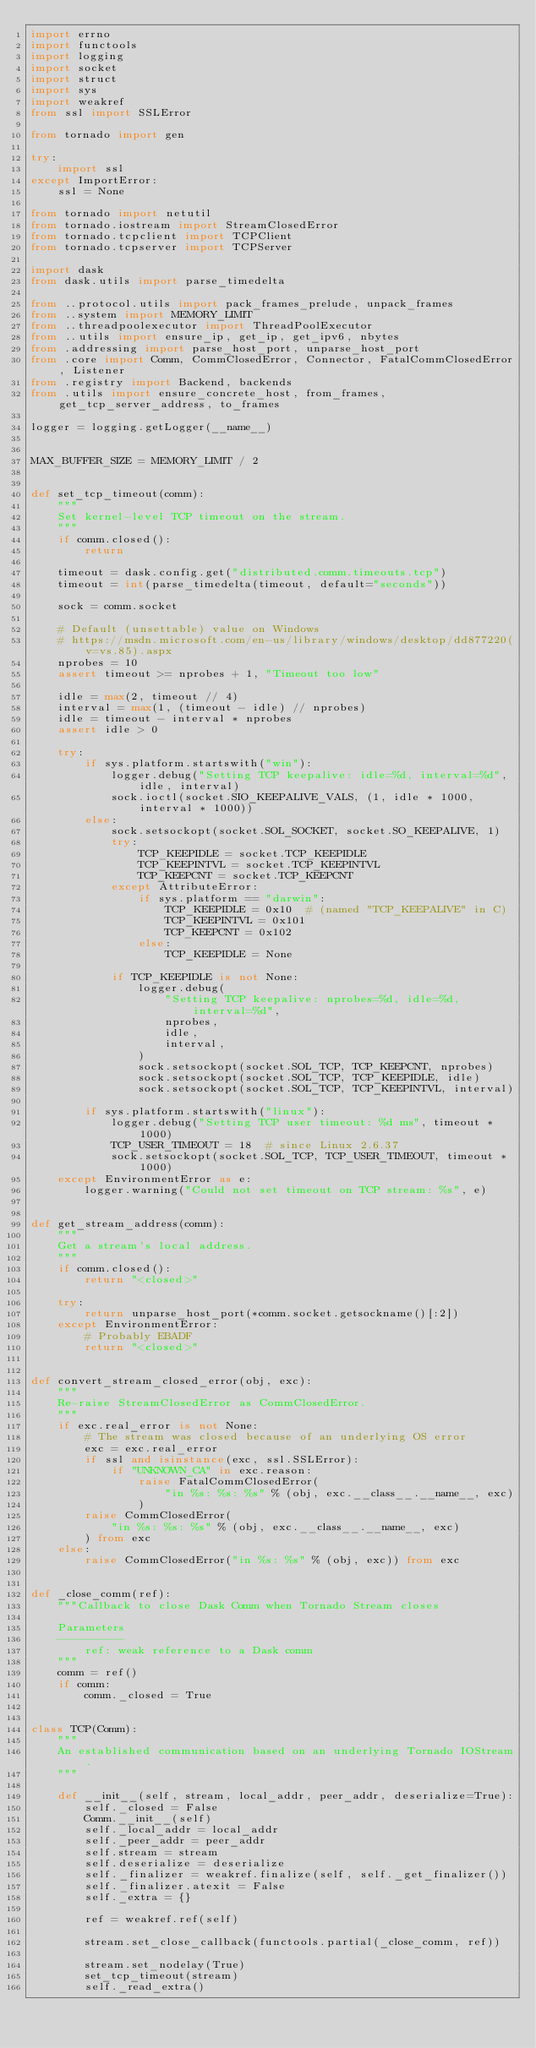<code> <loc_0><loc_0><loc_500><loc_500><_Python_>import errno
import functools
import logging
import socket
import struct
import sys
import weakref
from ssl import SSLError

from tornado import gen

try:
    import ssl
except ImportError:
    ssl = None

from tornado import netutil
from tornado.iostream import StreamClosedError
from tornado.tcpclient import TCPClient
from tornado.tcpserver import TCPServer

import dask
from dask.utils import parse_timedelta

from ..protocol.utils import pack_frames_prelude, unpack_frames
from ..system import MEMORY_LIMIT
from ..threadpoolexecutor import ThreadPoolExecutor
from ..utils import ensure_ip, get_ip, get_ipv6, nbytes
from .addressing import parse_host_port, unparse_host_port
from .core import Comm, CommClosedError, Connector, FatalCommClosedError, Listener
from .registry import Backend, backends
from .utils import ensure_concrete_host, from_frames, get_tcp_server_address, to_frames

logger = logging.getLogger(__name__)


MAX_BUFFER_SIZE = MEMORY_LIMIT / 2


def set_tcp_timeout(comm):
    """
    Set kernel-level TCP timeout on the stream.
    """
    if comm.closed():
        return

    timeout = dask.config.get("distributed.comm.timeouts.tcp")
    timeout = int(parse_timedelta(timeout, default="seconds"))

    sock = comm.socket

    # Default (unsettable) value on Windows
    # https://msdn.microsoft.com/en-us/library/windows/desktop/dd877220(v=vs.85).aspx
    nprobes = 10
    assert timeout >= nprobes + 1, "Timeout too low"

    idle = max(2, timeout // 4)
    interval = max(1, (timeout - idle) // nprobes)
    idle = timeout - interval * nprobes
    assert idle > 0

    try:
        if sys.platform.startswith("win"):
            logger.debug("Setting TCP keepalive: idle=%d, interval=%d", idle, interval)
            sock.ioctl(socket.SIO_KEEPALIVE_VALS, (1, idle * 1000, interval * 1000))
        else:
            sock.setsockopt(socket.SOL_SOCKET, socket.SO_KEEPALIVE, 1)
            try:
                TCP_KEEPIDLE = socket.TCP_KEEPIDLE
                TCP_KEEPINTVL = socket.TCP_KEEPINTVL
                TCP_KEEPCNT = socket.TCP_KEEPCNT
            except AttributeError:
                if sys.platform == "darwin":
                    TCP_KEEPIDLE = 0x10  # (named "TCP_KEEPALIVE" in C)
                    TCP_KEEPINTVL = 0x101
                    TCP_KEEPCNT = 0x102
                else:
                    TCP_KEEPIDLE = None

            if TCP_KEEPIDLE is not None:
                logger.debug(
                    "Setting TCP keepalive: nprobes=%d, idle=%d, interval=%d",
                    nprobes,
                    idle,
                    interval,
                )
                sock.setsockopt(socket.SOL_TCP, TCP_KEEPCNT, nprobes)
                sock.setsockopt(socket.SOL_TCP, TCP_KEEPIDLE, idle)
                sock.setsockopt(socket.SOL_TCP, TCP_KEEPINTVL, interval)

        if sys.platform.startswith("linux"):
            logger.debug("Setting TCP user timeout: %d ms", timeout * 1000)
            TCP_USER_TIMEOUT = 18  # since Linux 2.6.37
            sock.setsockopt(socket.SOL_TCP, TCP_USER_TIMEOUT, timeout * 1000)
    except EnvironmentError as e:
        logger.warning("Could not set timeout on TCP stream: %s", e)


def get_stream_address(comm):
    """
    Get a stream's local address.
    """
    if comm.closed():
        return "<closed>"

    try:
        return unparse_host_port(*comm.socket.getsockname()[:2])
    except EnvironmentError:
        # Probably EBADF
        return "<closed>"


def convert_stream_closed_error(obj, exc):
    """
    Re-raise StreamClosedError as CommClosedError.
    """
    if exc.real_error is not None:
        # The stream was closed because of an underlying OS error
        exc = exc.real_error
        if ssl and isinstance(exc, ssl.SSLError):
            if "UNKNOWN_CA" in exc.reason:
                raise FatalCommClosedError(
                    "in %s: %s: %s" % (obj, exc.__class__.__name__, exc)
                )
        raise CommClosedError(
            "in %s: %s: %s" % (obj, exc.__class__.__name__, exc)
        ) from exc
    else:
        raise CommClosedError("in %s: %s" % (obj, exc)) from exc


def _close_comm(ref):
    """Callback to close Dask Comm when Tornado Stream closes

    Parameters
    ----------
        ref: weak reference to a Dask comm
    """
    comm = ref()
    if comm:
        comm._closed = True


class TCP(Comm):
    """
    An established communication based on an underlying Tornado IOStream.
    """

    def __init__(self, stream, local_addr, peer_addr, deserialize=True):
        self._closed = False
        Comm.__init__(self)
        self._local_addr = local_addr
        self._peer_addr = peer_addr
        self.stream = stream
        self.deserialize = deserialize
        self._finalizer = weakref.finalize(self, self._get_finalizer())
        self._finalizer.atexit = False
        self._extra = {}

        ref = weakref.ref(self)

        stream.set_close_callback(functools.partial(_close_comm, ref))

        stream.set_nodelay(True)
        set_tcp_timeout(stream)
        self._read_extra()
</code> 